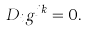<formula> <loc_0><loc_0><loc_500><loc_500>D _ { i } g ^ { j k } = 0 .</formula> 